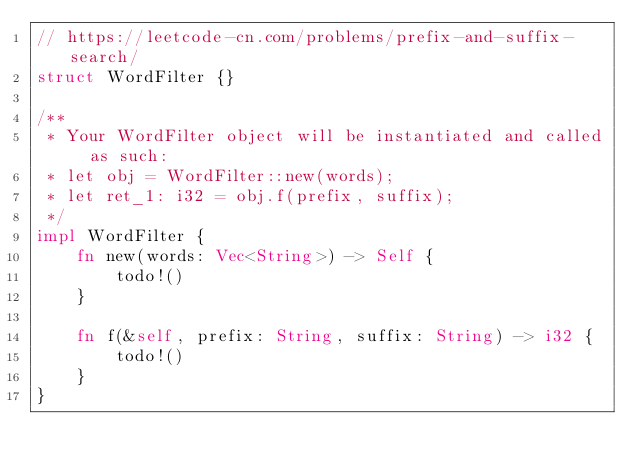<code> <loc_0><loc_0><loc_500><loc_500><_Rust_>// https://leetcode-cn.com/problems/prefix-and-suffix-search/
struct WordFilter {}

/**
 * Your WordFilter object will be instantiated and called as such:
 * let obj = WordFilter::new(words);
 * let ret_1: i32 = obj.f(prefix, suffix);
 */
impl WordFilter {
    fn new(words: Vec<String>) -> Self {
        todo!()
    }

    fn f(&self, prefix: String, suffix: String) -> i32 {
        todo!()
    }
}
</code> 